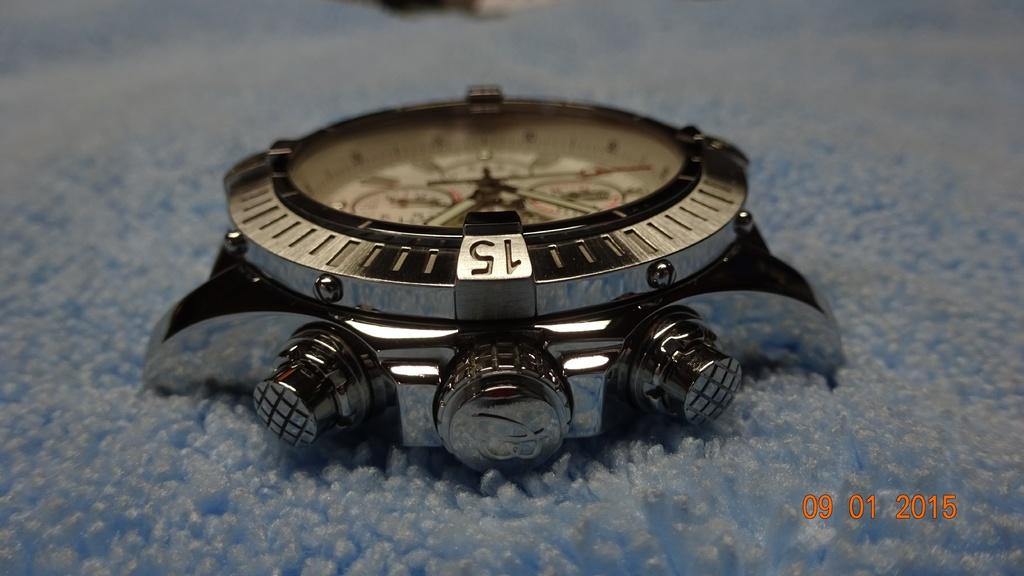<image>
Share a concise interpretation of the image provided. A watch with the number 15 written on top 